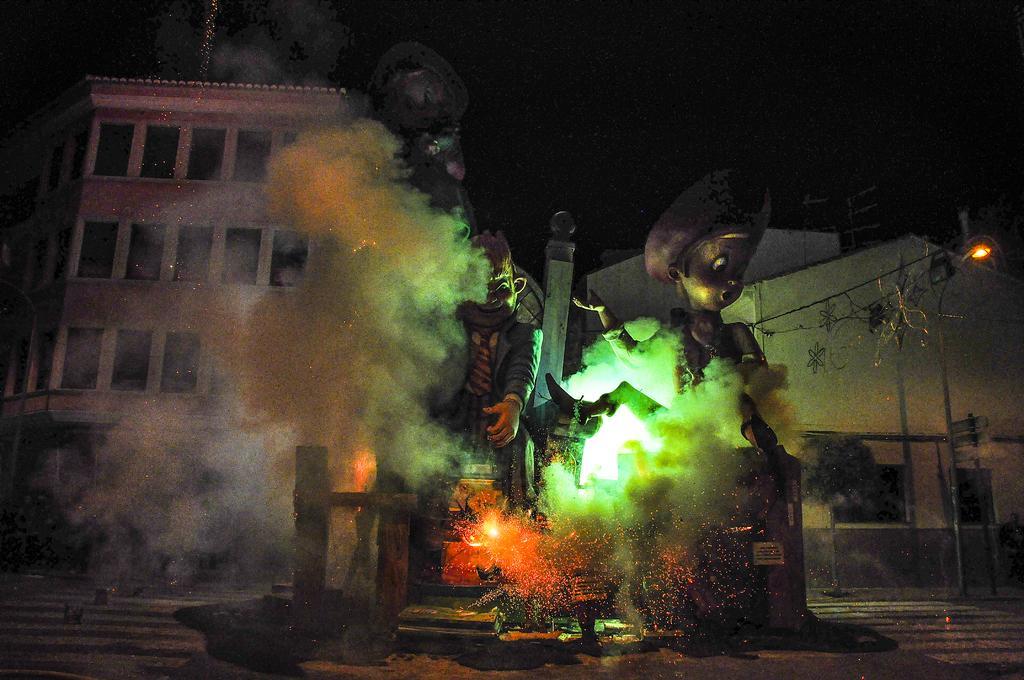In one or two sentences, can you explain what this image depicts? In this image we can see the statues. And we can see the glass windows, buildings such as houses. We can see the dark background. 